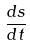<formula> <loc_0><loc_0><loc_500><loc_500>\frac { d s } { d t }</formula> 